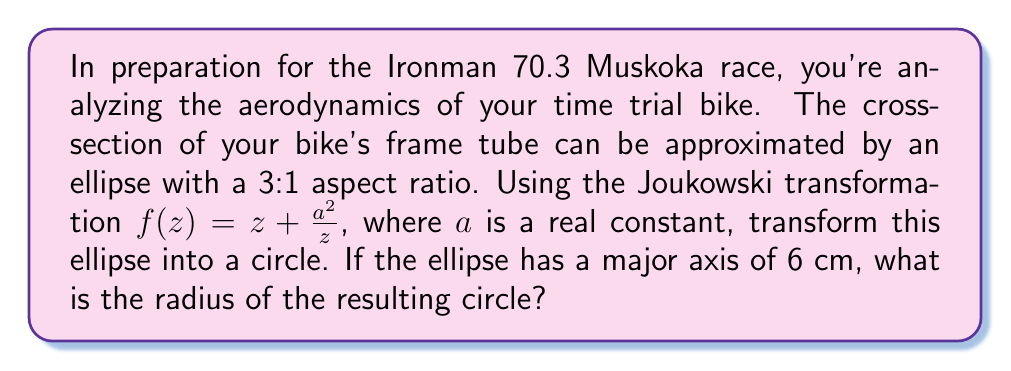Can you answer this question? To solve this problem, we'll follow these steps:

1) The Joukowski transformation $f(z) = z + \frac{a^2}{z}$ maps a circle to an airfoil shape. We'll use its inverse to map our ellipse to a circle.

2) For an ellipse with a 3:1 aspect ratio and major axis of 6 cm, the semi-major axis is 3 cm and the semi-minor axis is 1 cm.

3) The inverse Joukowski transformation that maps an ellipse to a circle is given by:

   $$z = \frac{w}{2} \pm \sqrt{\frac{w^2}{4} - a^2}$$

   where $w = f(z)$ is a point on the ellipse.

4) For an ellipse centered at the origin, the relationship between $a$ and the semi-axes is:

   $$a = \frac{l - s}{2}$$

   where $l$ is the semi-major axis and $s$ is the semi-minor axis.

5) In our case:
   $l = 3$ cm, $s = 1$ cm
   $$a = \frac{3 - 1}{2} = 1$$ cm

6) The radius $R$ of the circle resulting from this transformation is given by:

   $$R = \frac{l + s}{2}$$

7) Substituting our values:

   $$R = \frac{3 + 1}{2} = 2$$ cm

Therefore, the radius of the resulting circle is 2 cm.
Answer: 2 cm 